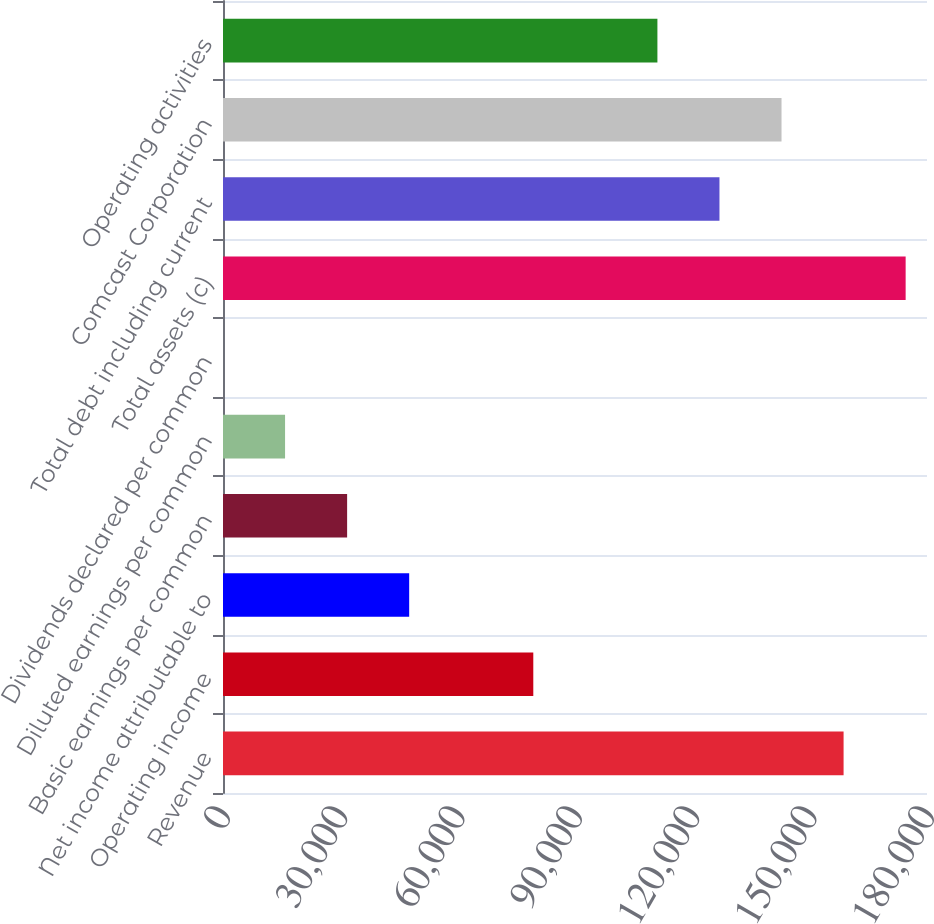Convert chart to OTSL. <chart><loc_0><loc_0><loc_500><loc_500><bar_chart><fcel>Revenue<fcel>Operating income<fcel>Net income attributable to<fcel>Basic earnings per common<fcel>Diluted earnings per common<fcel>Dividends declared per common<fcel>Total assets (c)<fcel>Total debt including current<fcel>Comcast Corporation<fcel>Operating activities<nl><fcel>158672<fcel>79336.4<fcel>47602.1<fcel>31735<fcel>15867.9<fcel>0.78<fcel>174539<fcel>126938<fcel>142805<fcel>111071<nl></chart> 